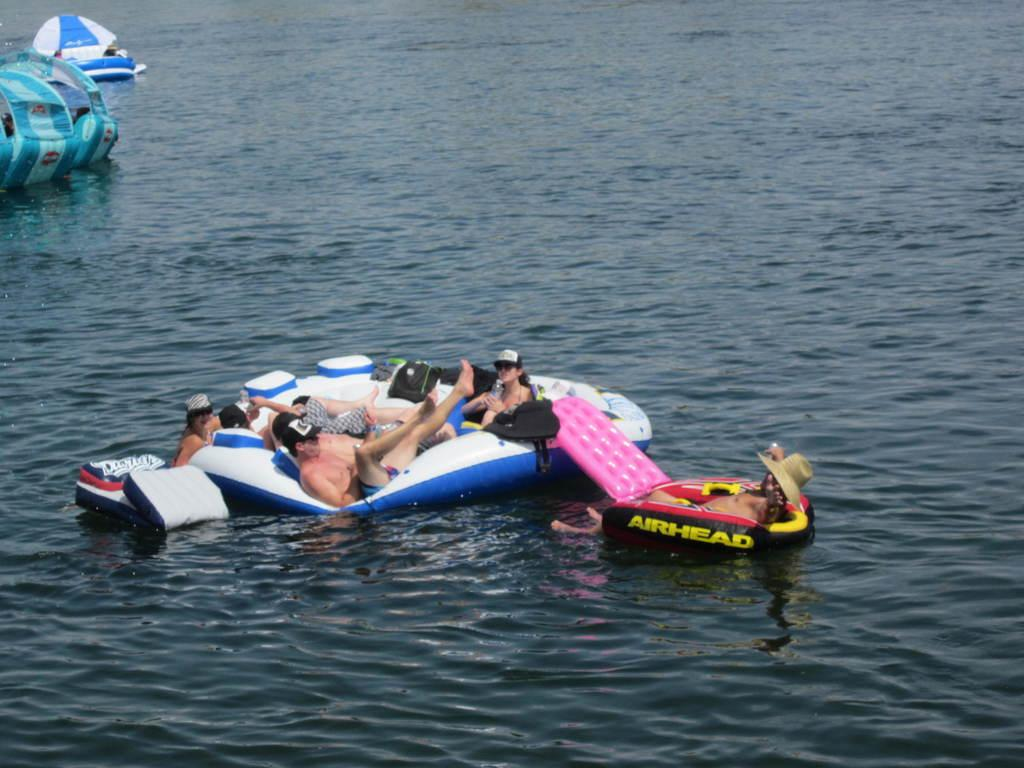<image>
Share a concise interpretation of the image provided. a crew of people floating in the water on a float by airhead 